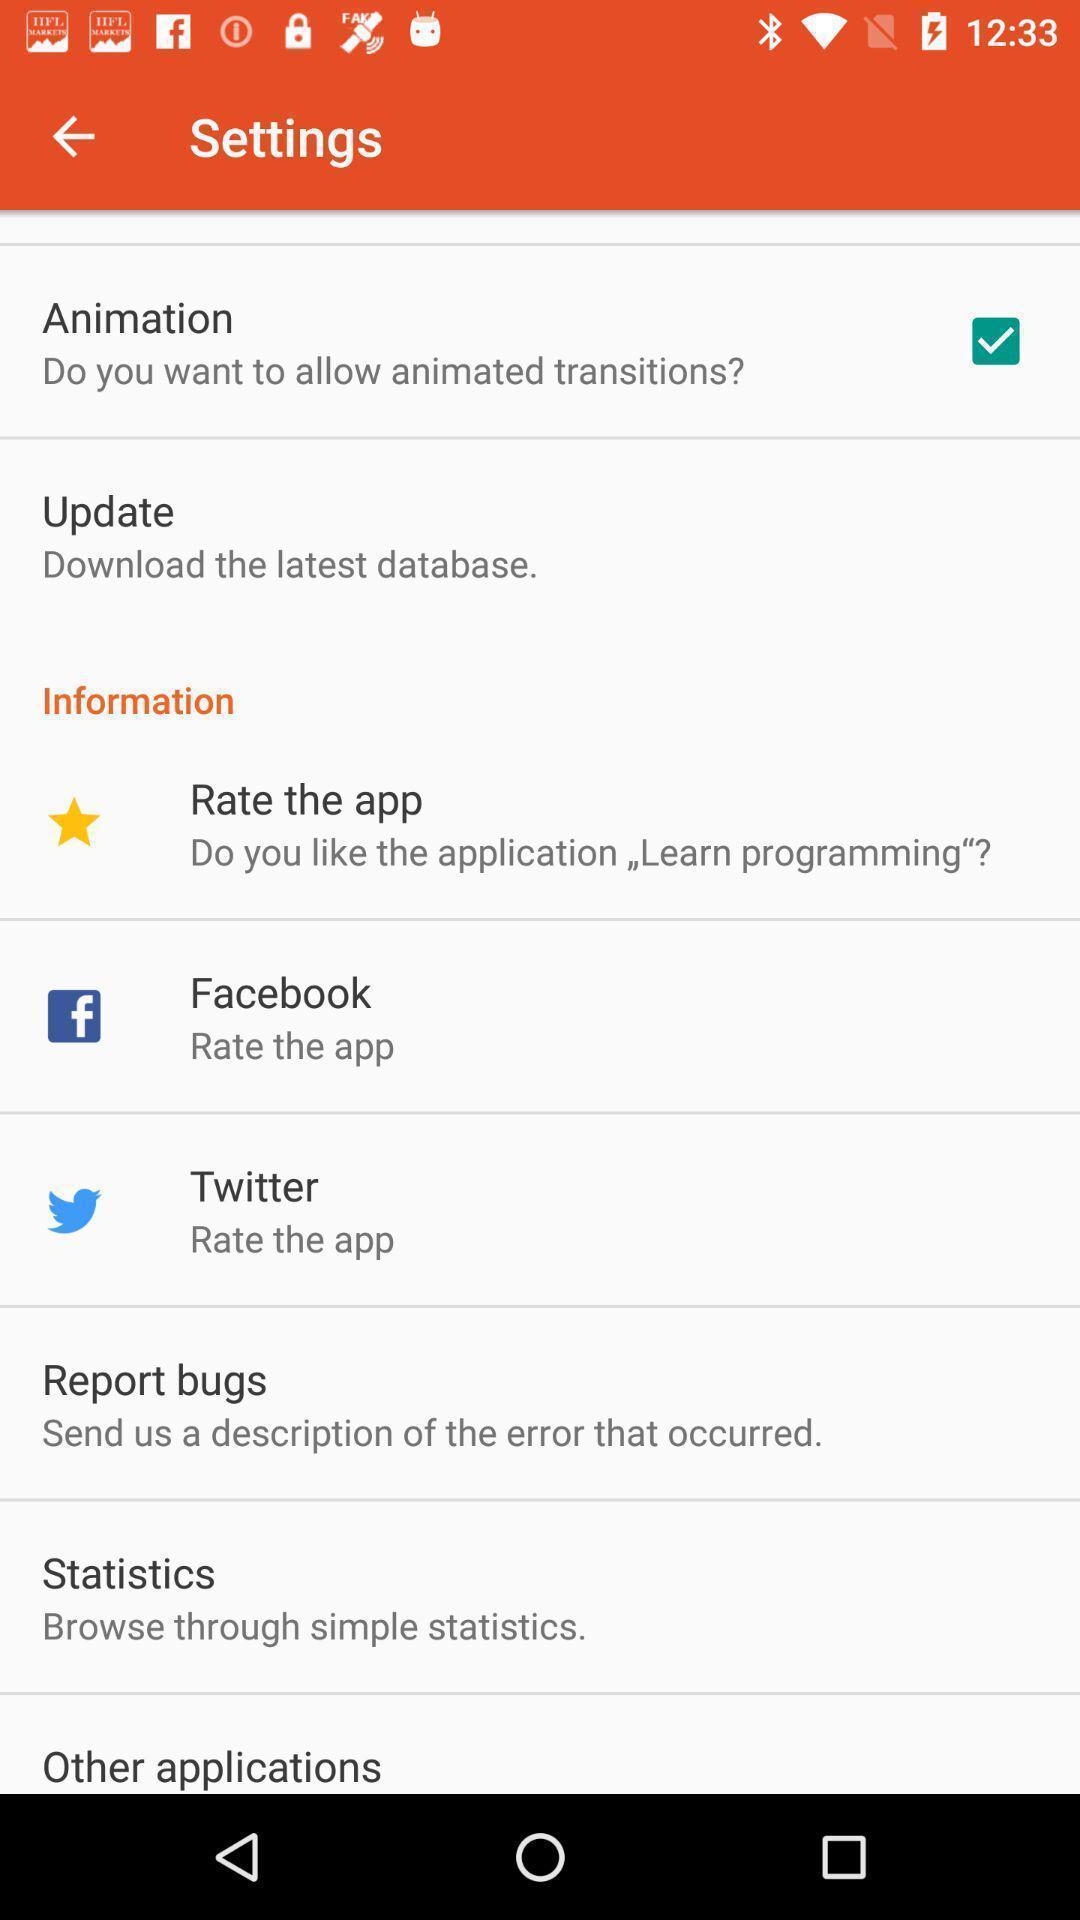Tell me about the visual elements in this screen capture. Setting page displaying various options. 